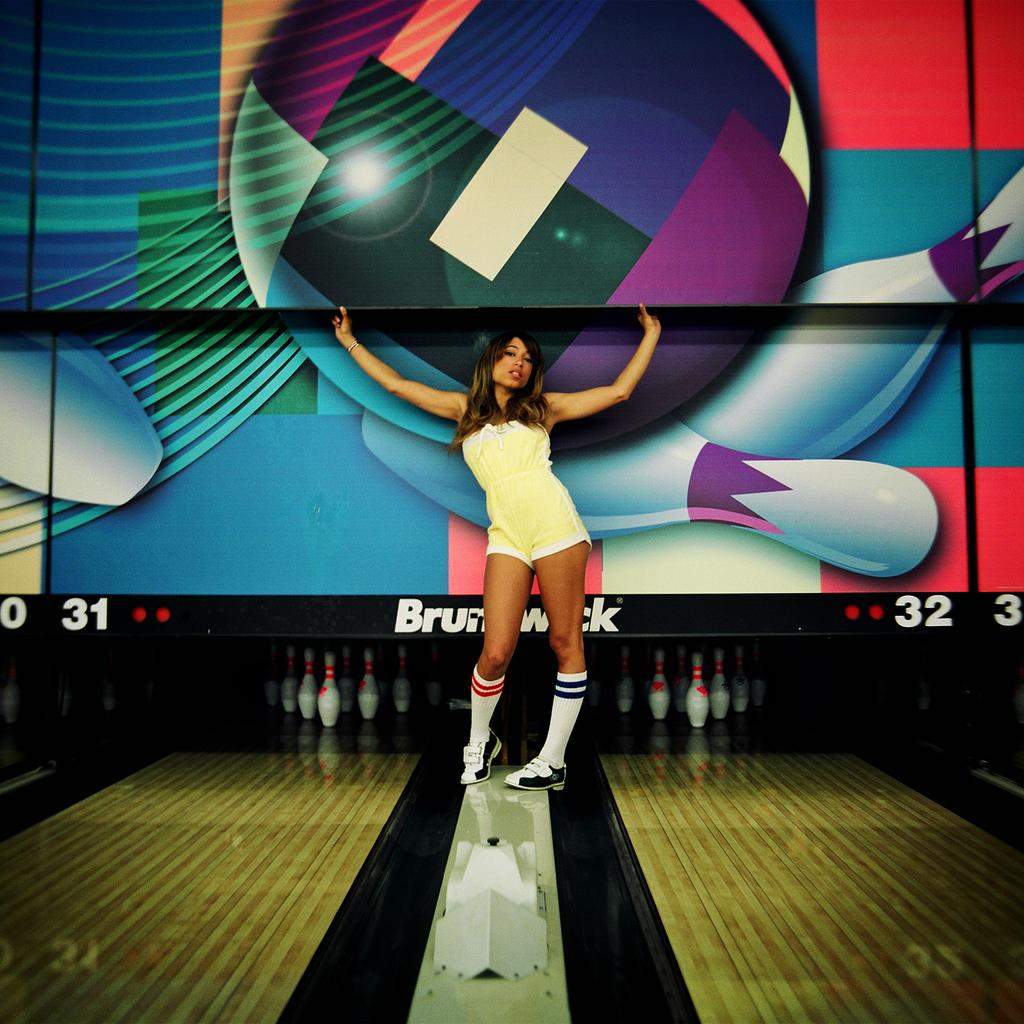Who is the main subject in the image? There is a woman in the image. What is the woman doing in the image? The woman is standing in front of bowling pins. What might be the purpose of her standing in front of the bowling pins? The woman is posing for a photo. What type of birds can be seen flying in the background of the image? There are no birds visible in the image. 